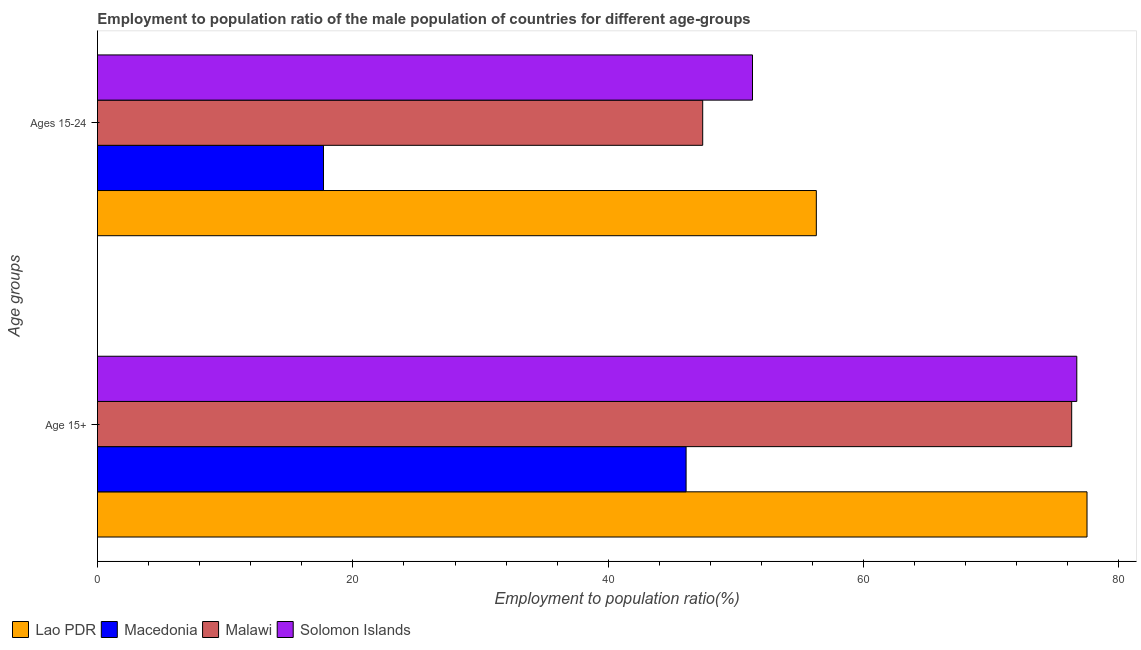Are the number of bars per tick equal to the number of legend labels?
Give a very brief answer. Yes. Are the number of bars on each tick of the Y-axis equal?
Give a very brief answer. Yes. How many bars are there on the 2nd tick from the bottom?
Offer a very short reply. 4. What is the label of the 2nd group of bars from the top?
Ensure brevity in your answer.  Age 15+. What is the employment to population ratio(age 15+) in Macedonia?
Offer a terse response. 46.1. Across all countries, what is the maximum employment to population ratio(age 15+)?
Your response must be concise. 77.5. Across all countries, what is the minimum employment to population ratio(age 15+)?
Offer a terse response. 46.1. In which country was the employment to population ratio(age 15+) maximum?
Your answer should be very brief. Lao PDR. In which country was the employment to population ratio(age 15-24) minimum?
Your answer should be very brief. Macedonia. What is the total employment to population ratio(age 15-24) in the graph?
Provide a short and direct response. 172.7. What is the difference between the employment to population ratio(age 15-24) in Macedonia and that in Malawi?
Provide a short and direct response. -29.7. What is the difference between the employment to population ratio(age 15+) in Solomon Islands and the employment to population ratio(age 15-24) in Macedonia?
Ensure brevity in your answer.  59. What is the average employment to population ratio(age 15+) per country?
Offer a terse response. 69.15. What is the difference between the employment to population ratio(age 15+) and employment to population ratio(age 15-24) in Lao PDR?
Ensure brevity in your answer.  21.2. In how many countries, is the employment to population ratio(age 15-24) greater than 20 %?
Offer a very short reply. 3. What is the ratio of the employment to population ratio(age 15-24) in Solomon Islands to that in Macedonia?
Offer a terse response. 2.9. What does the 1st bar from the top in Age 15+ represents?
Your answer should be compact. Solomon Islands. What does the 1st bar from the bottom in Age 15+ represents?
Give a very brief answer. Lao PDR. How many bars are there?
Your answer should be compact. 8. Are the values on the major ticks of X-axis written in scientific E-notation?
Provide a succinct answer. No. Does the graph contain any zero values?
Give a very brief answer. No. What is the title of the graph?
Offer a terse response. Employment to population ratio of the male population of countries for different age-groups. Does "South Asia" appear as one of the legend labels in the graph?
Give a very brief answer. No. What is the label or title of the Y-axis?
Give a very brief answer. Age groups. What is the Employment to population ratio(%) of Lao PDR in Age 15+?
Offer a very short reply. 77.5. What is the Employment to population ratio(%) in Macedonia in Age 15+?
Offer a terse response. 46.1. What is the Employment to population ratio(%) in Malawi in Age 15+?
Offer a very short reply. 76.3. What is the Employment to population ratio(%) in Solomon Islands in Age 15+?
Make the answer very short. 76.7. What is the Employment to population ratio(%) in Lao PDR in Ages 15-24?
Offer a very short reply. 56.3. What is the Employment to population ratio(%) in Macedonia in Ages 15-24?
Provide a short and direct response. 17.7. What is the Employment to population ratio(%) in Malawi in Ages 15-24?
Your response must be concise. 47.4. What is the Employment to population ratio(%) of Solomon Islands in Ages 15-24?
Provide a short and direct response. 51.3. Across all Age groups, what is the maximum Employment to population ratio(%) in Lao PDR?
Offer a terse response. 77.5. Across all Age groups, what is the maximum Employment to population ratio(%) in Macedonia?
Offer a very short reply. 46.1. Across all Age groups, what is the maximum Employment to population ratio(%) in Malawi?
Your answer should be compact. 76.3. Across all Age groups, what is the maximum Employment to population ratio(%) in Solomon Islands?
Offer a very short reply. 76.7. Across all Age groups, what is the minimum Employment to population ratio(%) in Lao PDR?
Your answer should be compact. 56.3. Across all Age groups, what is the minimum Employment to population ratio(%) of Macedonia?
Offer a very short reply. 17.7. Across all Age groups, what is the minimum Employment to population ratio(%) in Malawi?
Keep it short and to the point. 47.4. Across all Age groups, what is the minimum Employment to population ratio(%) of Solomon Islands?
Offer a very short reply. 51.3. What is the total Employment to population ratio(%) in Lao PDR in the graph?
Provide a short and direct response. 133.8. What is the total Employment to population ratio(%) in Macedonia in the graph?
Make the answer very short. 63.8. What is the total Employment to population ratio(%) of Malawi in the graph?
Provide a succinct answer. 123.7. What is the total Employment to population ratio(%) of Solomon Islands in the graph?
Make the answer very short. 128. What is the difference between the Employment to population ratio(%) in Lao PDR in Age 15+ and that in Ages 15-24?
Give a very brief answer. 21.2. What is the difference between the Employment to population ratio(%) in Macedonia in Age 15+ and that in Ages 15-24?
Your answer should be very brief. 28.4. What is the difference between the Employment to population ratio(%) of Malawi in Age 15+ and that in Ages 15-24?
Keep it short and to the point. 28.9. What is the difference between the Employment to population ratio(%) of Solomon Islands in Age 15+ and that in Ages 15-24?
Your answer should be very brief. 25.4. What is the difference between the Employment to population ratio(%) in Lao PDR in Age 15+ and the Employment to population ratio(%) in Macedonia in Ages 15-24?
Make the answer very short. 59.8. What is the difference between the Employment to population ratio(%) in Lao PDR in Age 15+ and the Employment to population ratio(%) in Malawi in Ages 15-24?
Offer a very short reply. 30.1. What is the difference between the Employment to population ratio(%) of Lao PDR in Age 15+ and the Employment to population ratio(%) of Solomon Islands in Ages 15-24?
Your answer should be very brief. 26.2. What is the difference between the Employment to population ratio(%) in Malawi in Age 15+ and the Employment to population ratio(%) in Solomon Islands in Ages 15-24?
Provide a succinct answer. 25. What is the average Employment to population ratio(%) of Lao PDR per Age groups?
Offer a very short reply. 66.9. What is the average Employment to population ratio(%) of Macedonia per Age groups?
Make the answer very short. 31.9. What is the average Employment to population ratio(%) in Malawi per Age groups?
Ensure brevity in your answer.  61.85. What is the difference between the Employment to population ratio(%) in Lao PDR and Employment to population ratio(%) in Macedonia in Age 15+?
Offer a very short reply. 31.4. What is the difference between the Employment to population ratio(%) in Macedonia and Employment to population ratio(%) in Malawi in Age 15+?
Keep it short and to the point. -30.2. What is the difference between the Employment to population ratio(%) in Macedonia and Employment to population ratio(%) in Solomon Islands in Age 15+?
Offer a very short reply. -30.6. What is the difference between the Employment to population ratio(%) in Malawi and Employment to population ratio(%) in Solomon Islands in Age 15+?
Give a very brief answer. -0.4. What is the difference between the Employment to population ratio(%) of Lao PDR and Employment to population ratio(%) of Macedonia in Ages 15-24?
Provide a succinct answer. 38.6. What is the difference between the Employment to population ratio(%) in Macedonia and Employment to population ratio(%) in Malawi in Ages 15-24?
Your answer should be very brief. -29.7. What is the difference between the Employment to population ratio(%) in Macedonia and Employment to population ratio(%) in Solomon Islands in Ages 15-24?
Ensure brevity in your answer.  -33.6. What is the ratio of the Employment to population ratio(%) in Lao PDR in Age 15+ to that in Ages 15-24?
Your response must be concise. 1.38. What is the ratio of the Employment to population ratio(%) in Macedonia in Age 15+ to that in Ages 15-24?
Your response must be concise. 2.6. What is the ratio of the Employment to population ratio(%) of Malawi in Age 15+ to that in Ages 15-24?
Make the answer very short. 1.61. What is the ratio of the Employment to population ratio(%) of Solomon Islands in Age 15+ to that in Ages 15-24?
Provide a short and direct response. 1.5. What is the difference between the highest and the second highest Employment to population ratio(%) of Lao PDR?
Your response must be concise. 21.2. What is the difference between the highest and the second highest Employment to population ratio(%) in Macedonia?
Your answer should be very brief. 28.4. What is the difference between the highest and the second highest Employment to population ratio(%) in Malawi?
Ensure brevity in your answer.  28.9. What is the difference between the highest and the second highest Employment to population ratio(%) of Solomon Islands?
Offer a very short reply. 25.4. What is the difference between the highest and the lowest Employment to population ratio(%) in Lao PDR?
Offer a terse response. 21.2. What is the difference between the highest and the lowest Employment to population ratio(%) in Macedonia?
Provide a short and direct response. 28.4. What is the difference between the highest and the lowest Employment to population ratio(%) in Malawi?
Give a very brief answer. 28.9. What is the difference between the highest and the lowest Employment to population ratio(%) in Solomon Islands?
Provide a short and direct response. 25.4. 